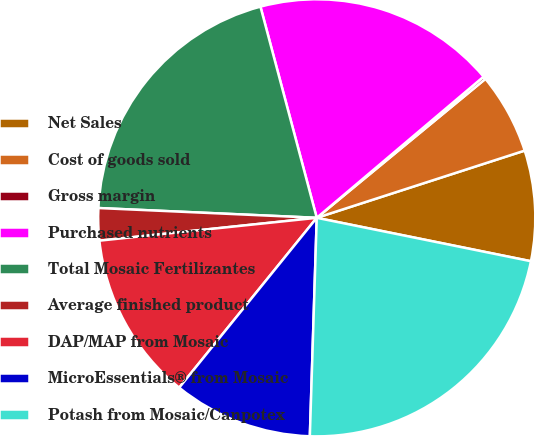Convert chart. <chart><loc_0><loc_0><loc_500><loc_500><pie_chart><fcel>Net Sales<fcel>Cost of goods sold<fcel>Gross margin<fcel>Purchased nutrients<fcel>Total Mosaic Fertilizantes<fcel>Average finished product<fcel>DAP/MAP from Mosaic<fcel>MicroEssentials® from Mosaic<fcel>Potash from Mosaic/Canpotex<nl><fcel>8.16%<fcel>5.99%<fcel>0.21%<fcel>17.97%<fcel>20.14%<fcel>2.38%<fcel>12.5%<fcel>10.33%<fcel>22.32%<nl></chart> 